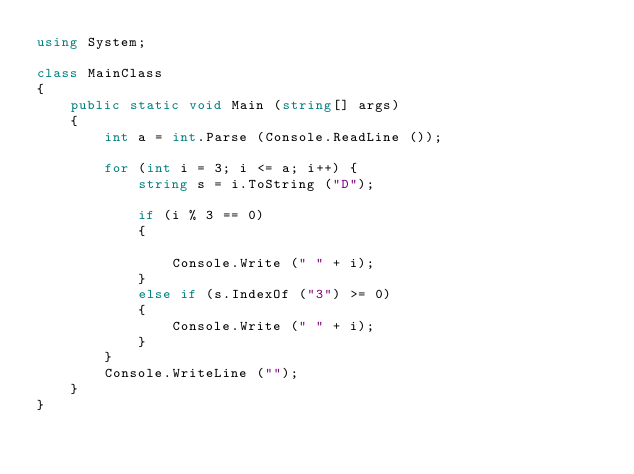Convert code to text. <code><loc_0><loc_0><loc_500><loc_500><_C#_>using System;

class MainClass
{
	public static void Main (string[] args)
	{
		int a = int.Parse (Console.ReadLine ());

		for (int i = 3; i <= a; i++) {
			string s = i.ToString ("D");

			if (i % 3 == 0)
			{
				
				Console.Write (" " + i);
			} 
			else if (s.IndexOf ("3") >= 0) 
			{
				Console.Write (" " + i);
			}
		}
		Console.WriteLine ("");
	}
}</code> 